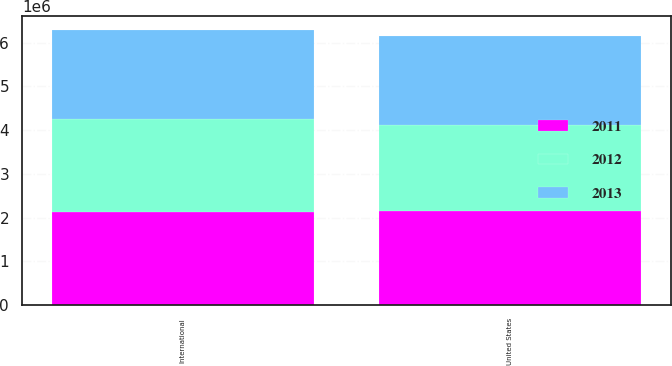Convert chart to OTSL. <chart><loc_0><loc_0><loc_500><loc_500><stacked_bar_chart><ecel><fcel>United States<fcel>International<nl><fcel>2012<fcel>1.96048e+06<fcel>2.12168e+06<nl><fcel>2013<fcel>2.04434e+06<fcel>2.04464e+06<nl><fcel>2011<fcel>2.15504e+06<fcel>2.13055e+06<nl></chart> 